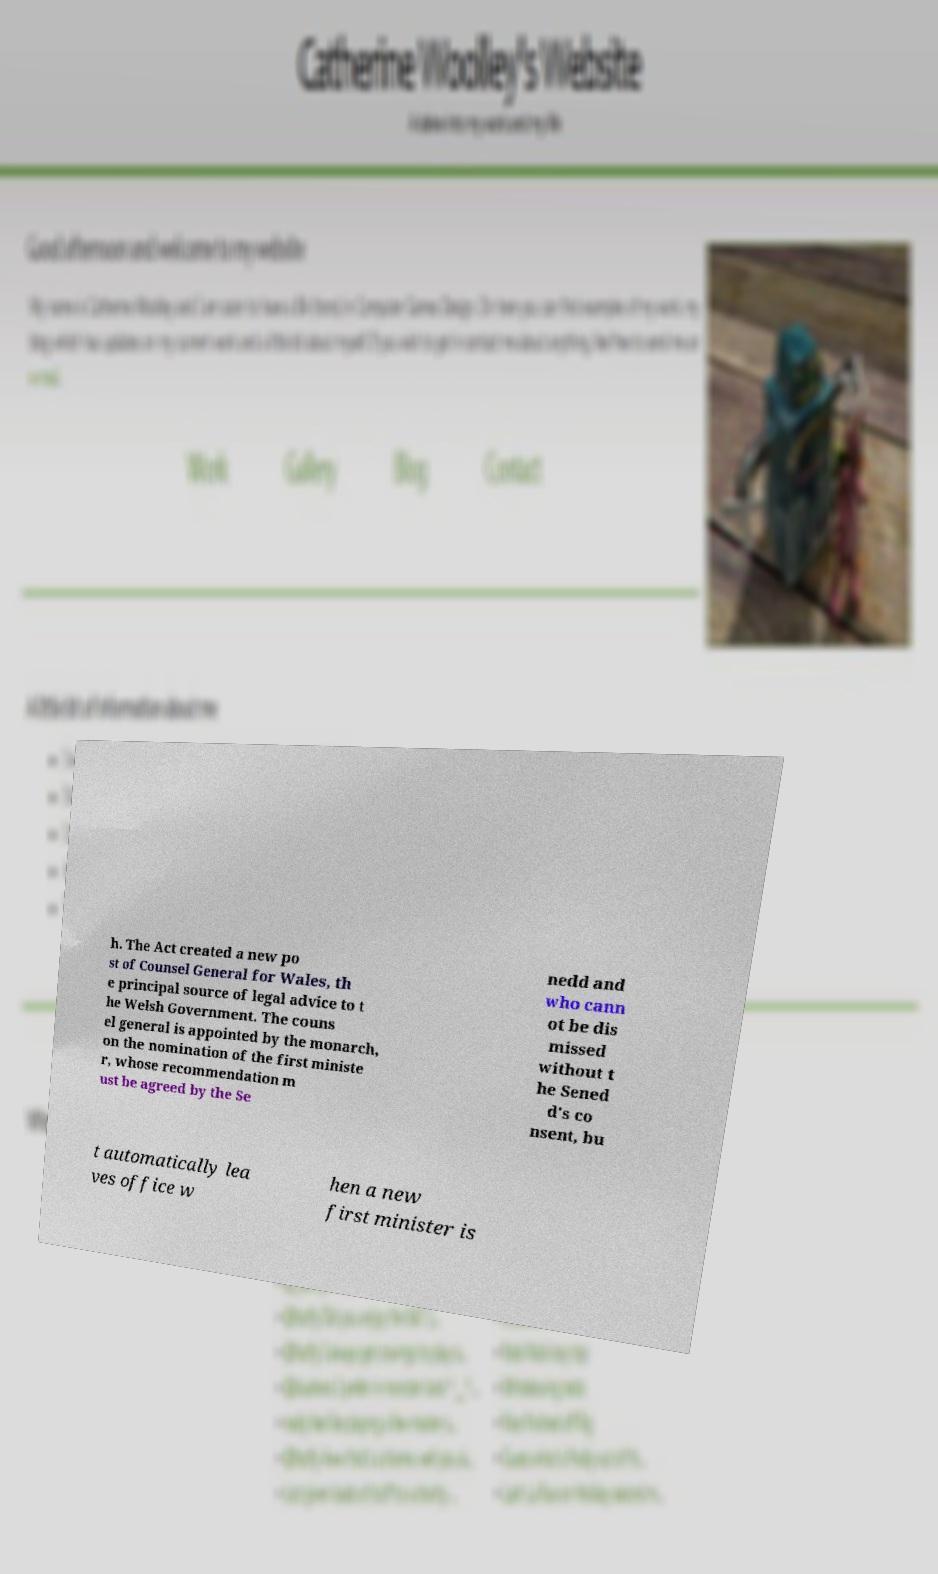Can you read and provide the text displayed in the image?This photo seems to have some interesting text. Can you extract and type it out for me? h. The Act created a new po st of Counsel General for Wales, th e principal source of legal advice to t he Welsh Government. The couns el general is appointed by the monarch, on the nomination of the first ministe r, whose recommendation m ust be agreed by the Se nedd and who cann ot be dis missed without t he Sened d's co nsent, bu t automatically lea ves office w hen a new first minister is 